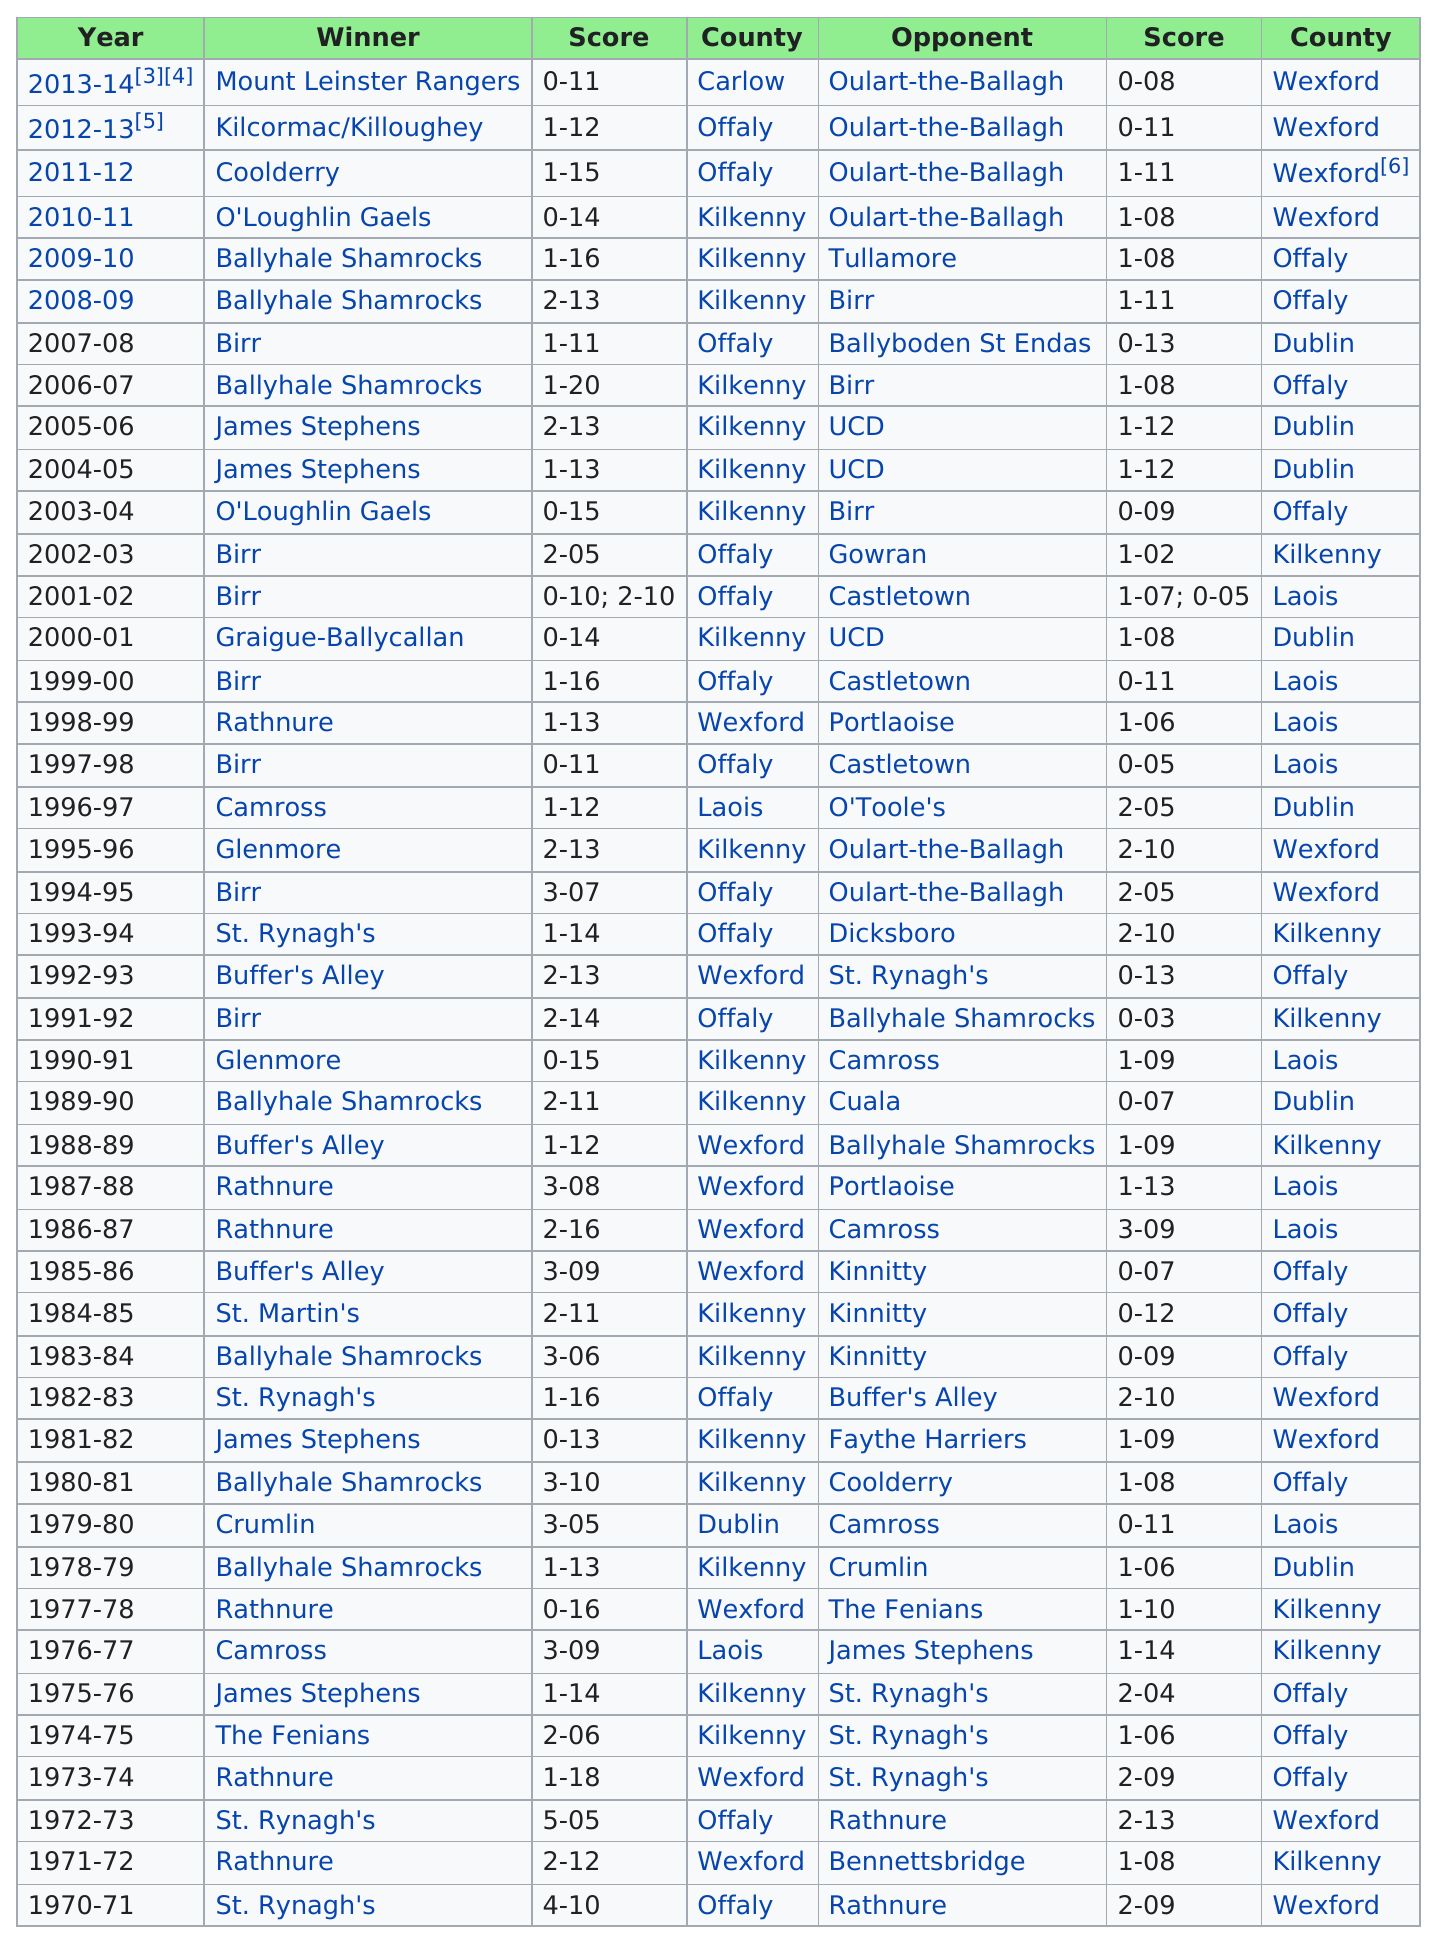Identify some key points in this picture. Kilkenny, the country, had the most wins. Rathnure won consecutively for 2 years. In the 2007-08 season of the Leinster Senior Club Hurling Championships, the winning team had a score differential of less than 11. The total score for Kilcormac/Killoughey is 1-12. The next winner in the Mount Leinster Rangers competition is Kilcormac/Killoughey. 